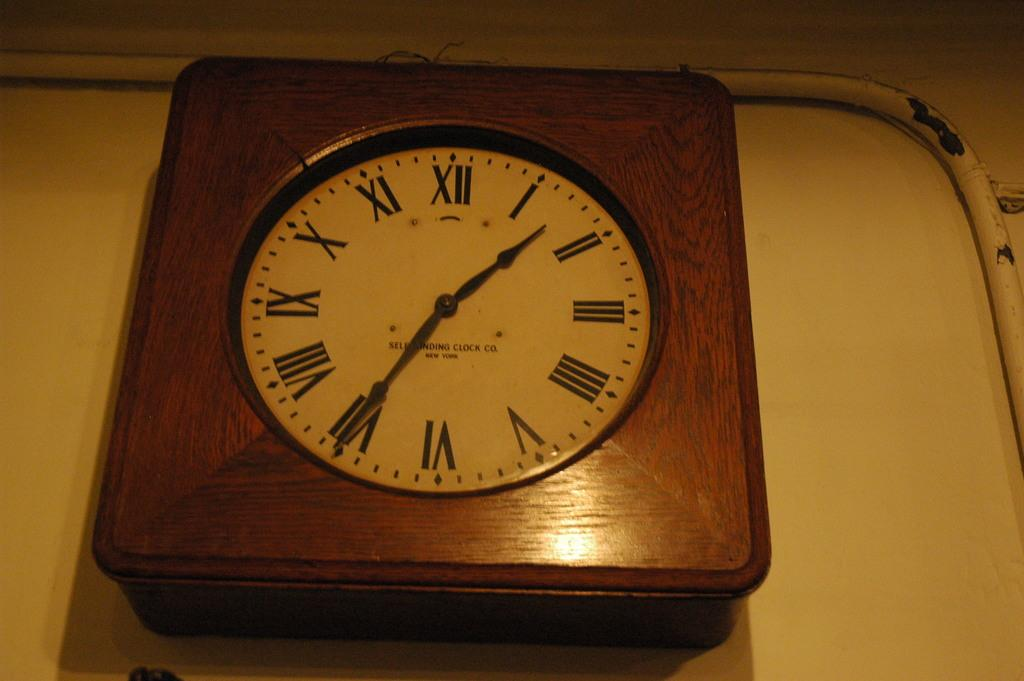<image>
Give a short and clear explanation of the subsequent image. A brown wood cased wall clock made by the Selfwinding Clock co, from New York 